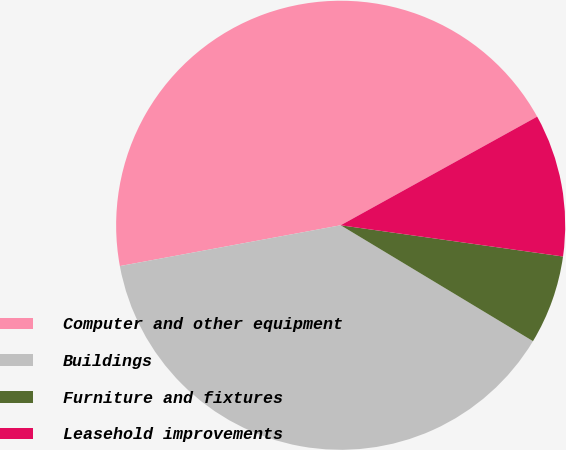Convert chart. <chart><loc_0><loc_0><loc_500><loc_500><pie_chart><fcel>Computer and other equipment<fcel>Buildings<fcel>Furniture and fixtures<fcel>Leasehold improvements<nl><fcel>44.87%<fcel>38.46%<fcel>6.41%<fcel>10.26%<nl></chart> 